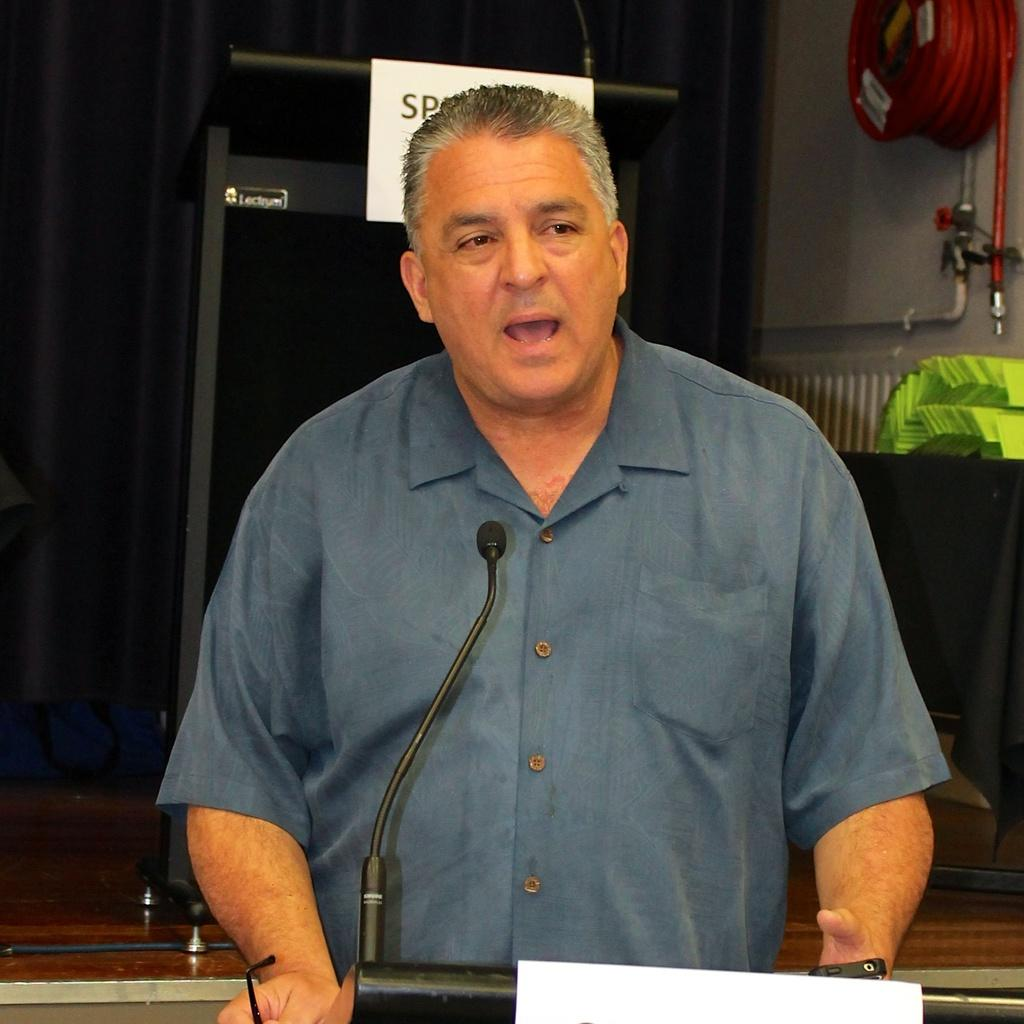What is the man in the image doing? The man is speaking in the microphone. What is the man wearing while speaking? The man is wearing a shirt. What object can be seen on the right side of the image? There is a fire extinguisher pipe on the right side of the image. How many jars are visible on the stage in the image? There are no jars visible in the image. What type of tail can be seen on the man while he is speaking? The man does not have a tail, as he is a human. 